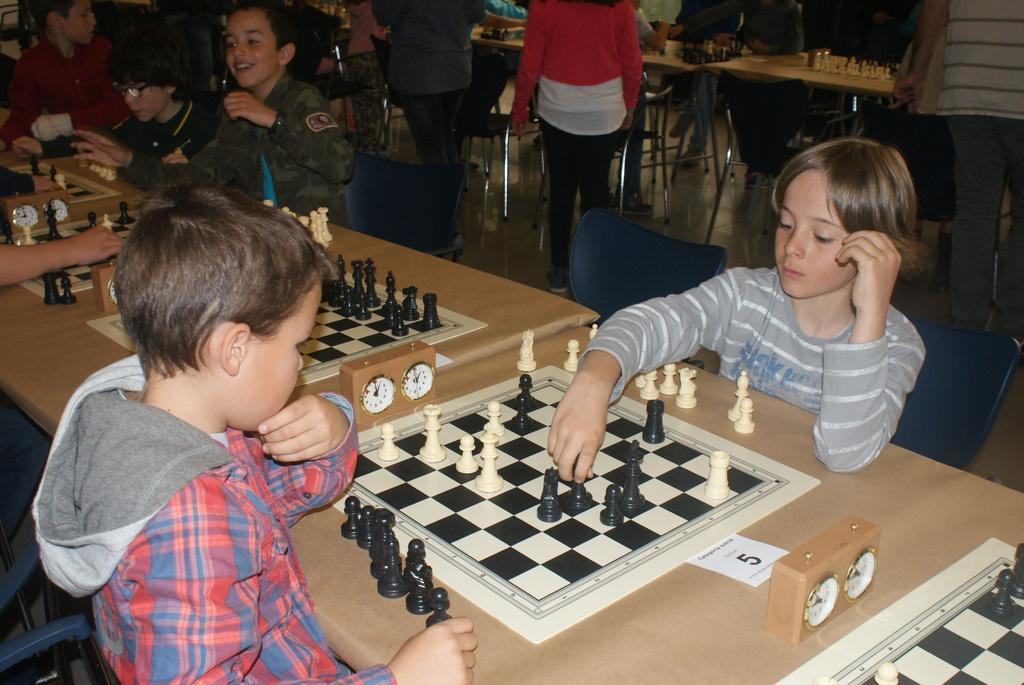Who is present in the image? There are children in the image. What are the children doing in the image? The children are sitting around a table. What is on the table in the image? There is a chess board and a clock on the table. How many chairs are visible in the image? There are many chairs in the image. What type of anger is being expressed by the children in the image? There is no indication of anger in the image; the children are sitting around a table and engaged in an activity. 